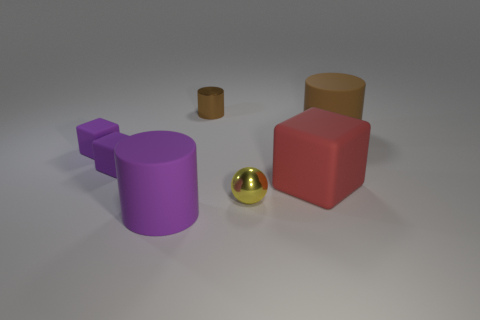Add 1 small cyan shiny cubes. How many objects exist? 8 Subtract all cubes. How many objects are left? 4 Subtract all large brown matte cylinders. Subtract all brown metallic objects. How many objects are left? 5 Add 1 large objects. How many large objects are left? 4 Add 1 blue blocks. How many blue blocks exist? 1 Subtract 2 brown cylinders. How many objects are left? 5 